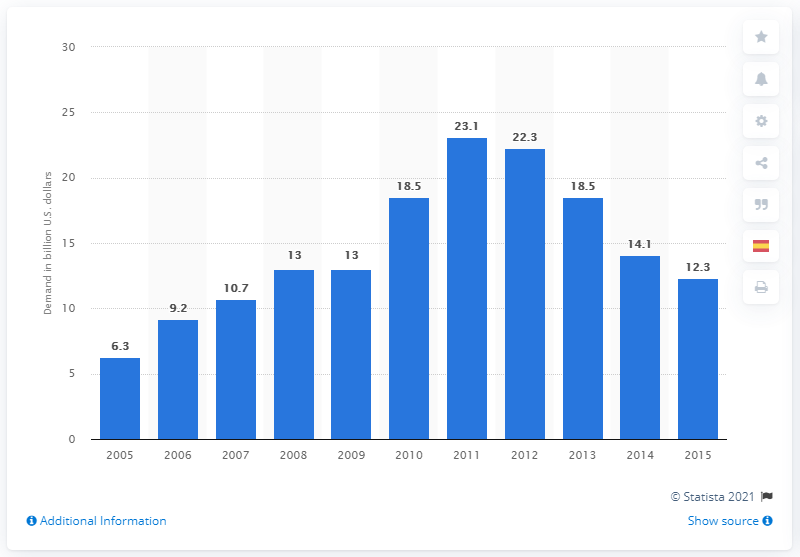Mention a couple of crucial points in this snapshot. In 2011, the global technology sector demanded a significant amount of gold, estimated to be 23.1 million ounces. 